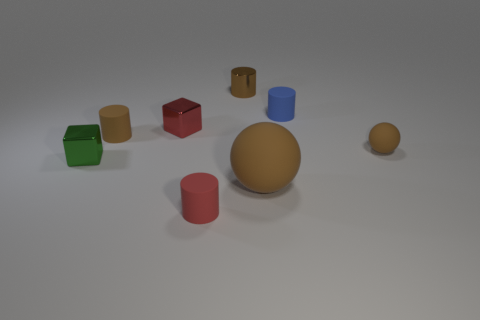What shapes are present in the image and how are they arranged? The image contains a variety of geometric shapes including a sphere, a cube, a cylinder, and what appears to be truncated cylinders or short prisms. They are arranged sporadically on a flat surface with no specific pattern. 